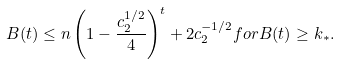Convert formula to latex. <formula><loc_0><loc_0><loc_500><loc_500>B ( t ) \leq n \left ( 1 - \frac { c _ { 2 } ^ { 1 / 2 } } { 4 } \right ) ^ { t } + 2 c _ { 2 } ^ { - 1 / 2 } f o r B ( t ) \geq k _ { * } .</formula> 